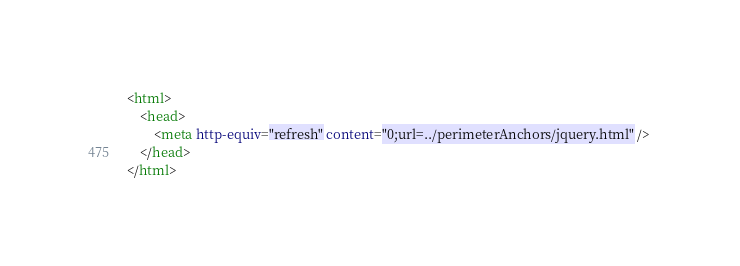Convert code to text. <code><loc_0><loc_0><loc_500><loc_500><_HTML_><html>
	<head>
		<meta http-equiv="refresh" content="0;url=../perimeterAnchors/jquery.html" /> 
	</head>
</html>
</code> 